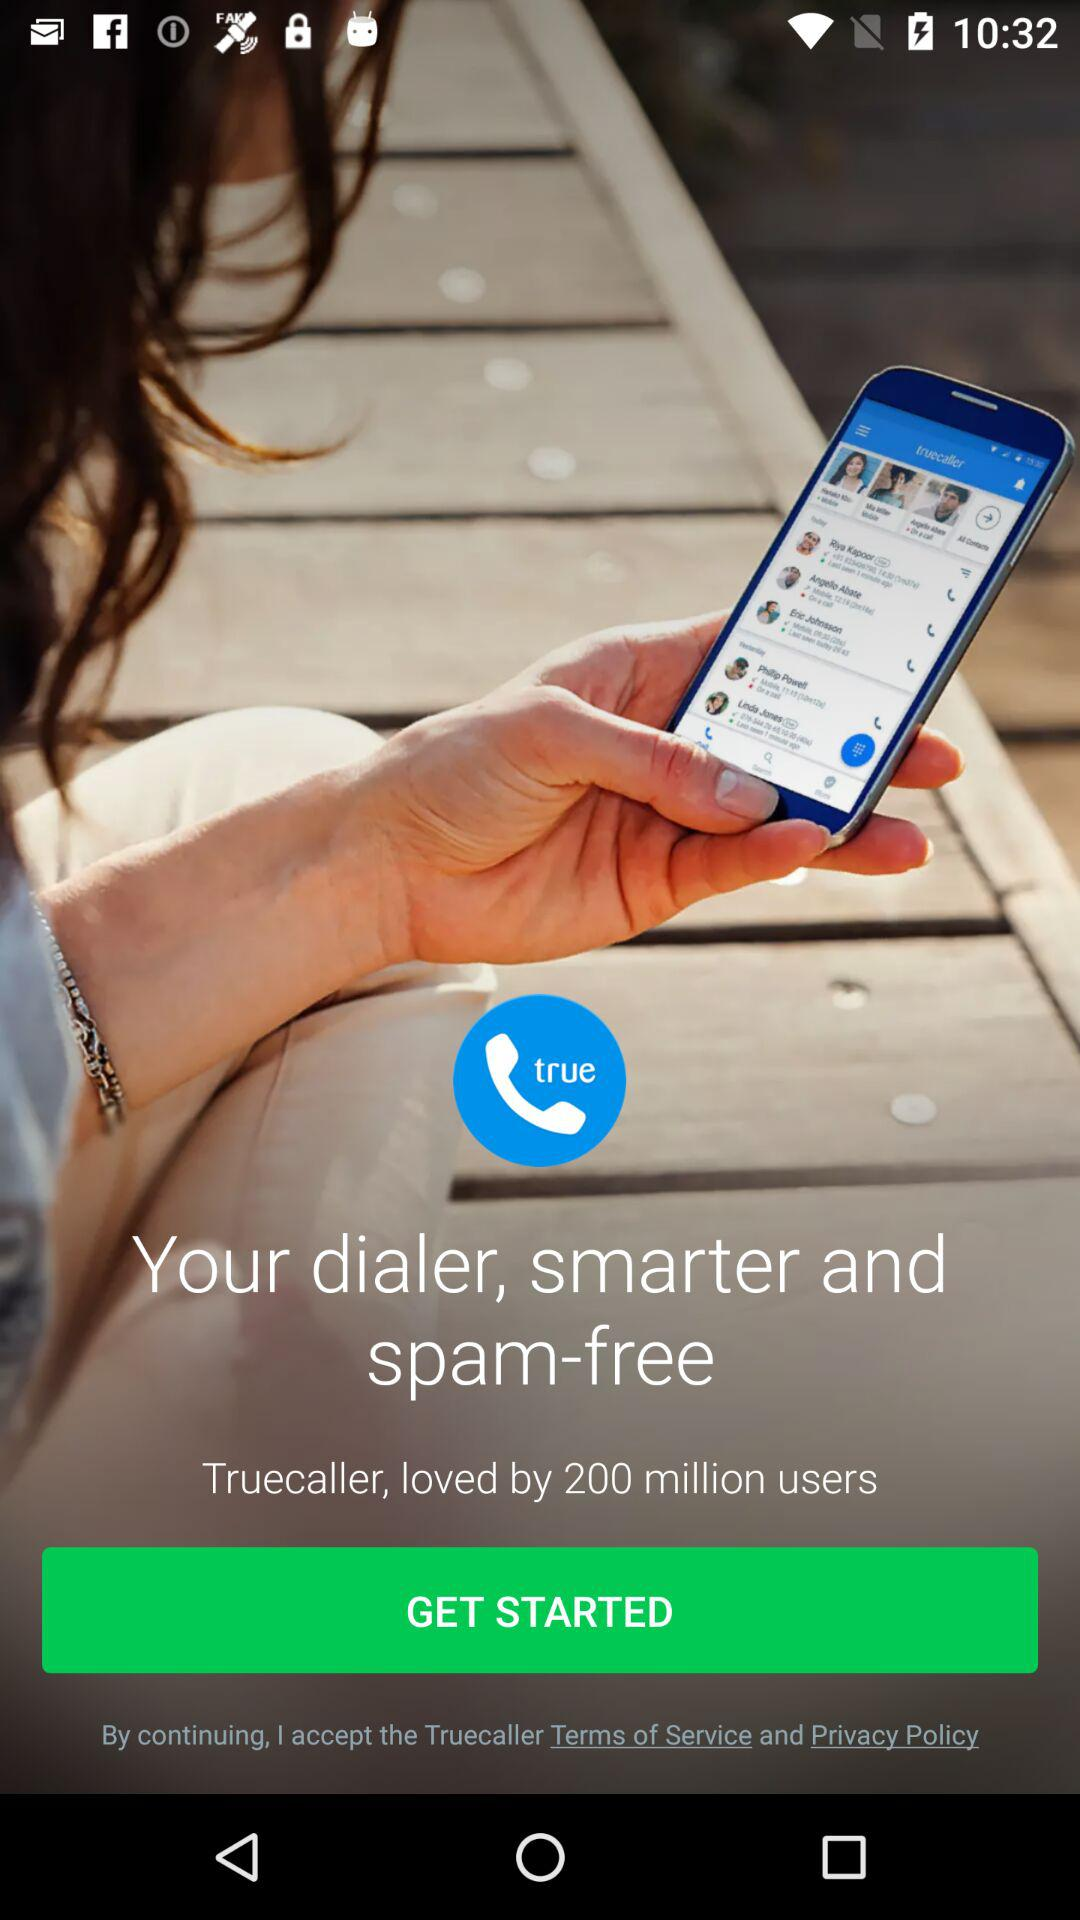How many users loved the "Truecaller" app? There are 200 million users who has loved the "Truecaller" app. 